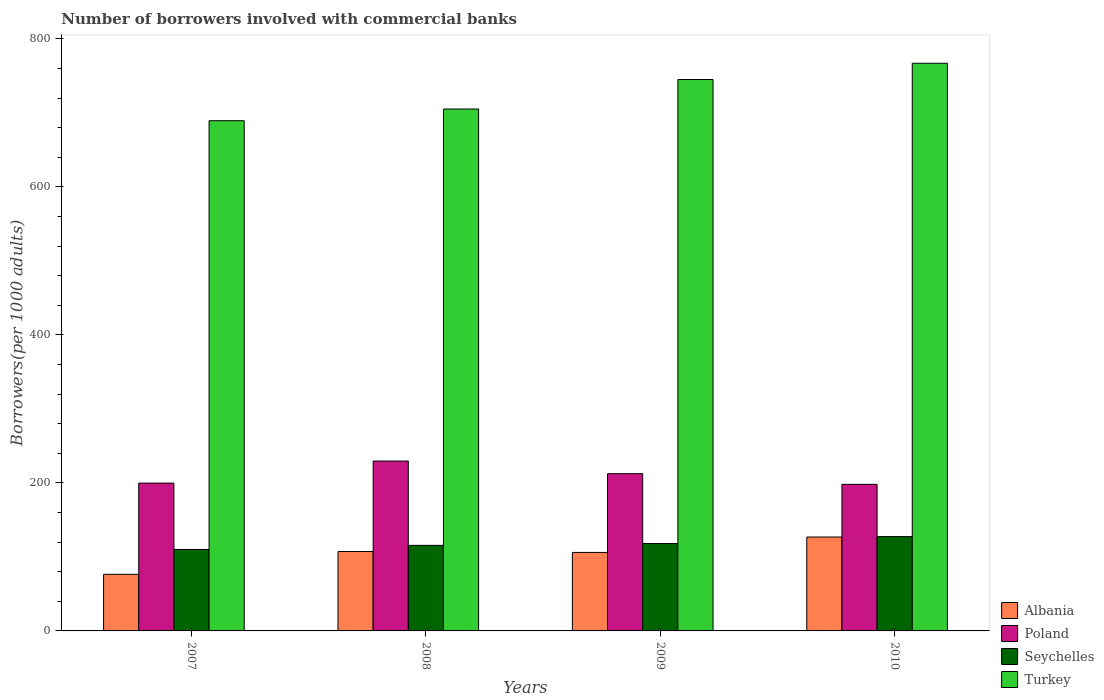How many different coloured bars are there?
Your answer should be compact. 4. How many groups of bars are there?
Provide a succinct answer. 4. Are the number of bars per tick equal to the number of legend labels?
Make the answer very short. Yes. Are the number of bars on each tick of the X-axis equal?
Keep it short and to the point. Yes. In how many cases, is the number of bars for a given year not equal to the number of legend labels?
Make the answer very short. 0. What is the number of borrowers involved with commercial banks in Turkey in 2008?
Your answer should be very brief. 705.18. Across all years, what is the maximum number of borrowers involved with commercial banks in Turkey?
Provide a succinct answer. 766.99. Across all years, what is the minimum number of borrowers involved with commercial banks in Poland?
Ensure brevity in your answer.  198.06. In which year was the number of borrowers involved with commercial banks in Turkey minimum?
Your response must be concise. 2007. What is the total number of borrowers involved with commercial banks in Turkey in the graph?
Offer a terse response. 2906.56. What is the difference between the number of borrowers involved with commercial banks in Turkey in 2007 and that in 2010?
Provide a short and direct response. -77.65. What is the difference between the number of borrowers involved with commercial banks in Seychelles in 2010 and the number of borrowers involved with commercial banks in Albania in 2009?
Your answer should be compact. 21.38. What is the average number of borrowers involved with commercial banks in Turkey per year?
Provide a succinct answer. 726.64. In the year 2009, what is the difference between the number of borrowers involved with commercial banks in Poland and number of borrowers involved with commercial banks in Albania?
Provide a short and direct response. 106.4. What is the ratio of the number of borrowers involved with commercial banks in Albania in 2007 to that in 2010?
Provide a short and direct response. 0.6. Is the number of borrowers involved with commercial banks in Poland in 2007 less than that in 2010?
Ensure brevity in your answer.  No. What is the difference between the highest and the second highest number of borrowers involved with commercial banks in Seychelles?
Offer a terse response. 9.37. What is the difference between the highest and the lowest number of borrowers involved with commercial banks in Seychelles?
Provide a short and direct response. 17.37. Is it the case that in every year, the sum of the number of borrowers involved with commercial banks in Turkey and number of borrowers involved with commercial banks in Seychelles is greater than the sum of number of borrowers involved with commercial banks in Albania and number of borrowers involved with commercial banks in Poland?
Offer a terse response. Yes. What does the 4th bar from the left in 2010 represents?
Give a very brief answer. Turkey. Is it the case that in every year, the sum of the number of borrowers involved with commercial banks in Turkey and number of borrowers involved with commercial banks in Albania is greater than the number of borrowers involved with commercial banks in Seychelles?
Make the answer very short. Yes. How many bars are there?
Offer a terse response. 16. Where does the legend appear in the graph?
Provide a succinct answer. Bottom right. How many legend labels are there?
Give a very brief answer. 4. What is the title of the graph?
Provide a succinct answer. Number of borrowers involved with commercial banks. What is the label or title of the X-axis?
Ensure brevity in your answer.  Years. What is the label or title of the Y-axis?
Provide a short and direct response. Borrowers(per 1000 adults). What is the Borrowers(per 1000 adults) in Albania in 2007?
Provide a short and direct response. 76.5. What is the Borrowers(per 1000 adults) of Poland in 2007?
Offer a very short reply. 199.74. What is the Borrowers(per 1000 adults) in Seychelles in 2007?
Give a very brief answer. 110.06. What is the Borrowers(per 1000 adults) in Turkey in 2007?
Make the answer very short. 689.34. What is the Borrowers(per 1000 adults) in Albania in 2008?
Provide a succinct answer. 107.27. What is the Borrowers(per 1000 adults) of Poland in 2008?
Keep it short and to the point. 229.51. What is the Borrowers(per 1000 adults) in Seychelles in 2008?
Ensure brevity in your answer.  115.61. What is the Borrowers(per 1000 adults) of Turkey in 2008?
Your answer should be compact. 705.18. What is the Borrowers(per 1000 adults) of Albania in 2009?
Keep it short and to the point. 106.05. What is the Borrowers(per 1000 adults) in Poland in 2009?
Provide a succinct answer. 212.45. What is the Borrowers(per 1000 adults) of Seychelles in 2009?
Your response must be concise. 118.06. What is the Borrowers(per 1000 adults) of Turkey in 2009?
Your answer should be very brief. 745.06. What is the Borrowers(per 1000 adults) of Albania in 2010?
Give a very brief answer. 126.87. What is the Borrowers(per 1000 adults) in Poland in 2010?
Keep it short and to the point. 198.06. What is the Borrowers(per 1000 adults) in Seychelles in 2010?
Provide a short and direct response. 127.43. What is the Borrowers(per 1000 adults) of Turkey in 2010?
Give a very brief answer. 766.99. Across all years, what is the maximum Borrowers(per 1000 adults) in Albania?
Your answer should be compact. 126.87. Across all years, what is the maximum Borrowers(per 1000 adults) of Poland?
Provide a short and direct response. 229.51. Across all years, what is the maximum Borrowers(per 1000 adults) in Seychelles?
Give a very brief answer. 127.43. Across all years, what is the maximum Borrowers(per 1000 adults) in Turkey?
Give a very brief answer. 766.99. Across all years, what is the minimum Borrowers(per 1000 adults) of Albania?
Provide a succinct answer. 76.5. Across all years, what is the minimum Borrowers(per 1000 adults) in Poland?
Offer a terse response. 198.06. Across all years, what is the minimum Borrowers(per 1000 adults) in Seychelles?
Make the answer very short. 110.06. Across all years, what is the minimum Borrowers(per 1000 adults) of Turkey?
Your answer should be compact. 689.34. What is the total Borrowers(per 1000 adults) of Albania in the graph?
Keep it short and to the point. 416.68. What is the total Borrowers(per 1000 adults) in Poland in the graph?
Your answer should be compact. 839.76. What is the total Borrowers(per 1000 adults) of Seychelles in the graph?
Provide a short and direct response. 471.15. What is the total Borrowers(per 1000 adults) in Turkey in the graph?
Offer a terse response. 2906.56. What is the difference between the Borrowers(per 1000 adults) of Albania in 2007 and that in 2008?
Provide a short and direct response. -30.78. What is the difference between the Borrowers(per 1000 adults) of Poland in 2007 and that in 2008?
Make the answer very short. -29.78. What is the difference between the Borrowers(per 1000 adults) in Seychelles in 2007 and that in 2008?
Provide a succinct answer. -5.55. What is the difference between the Borrowers(per 1000 adults) of Turkey in 2007 and that in 2008?
Offer a terse response. -15.83. What is the difference between the Borrowers(per 1000 adults) of Albania in 2007 and that in 2009?
Give a very brief answer. -29.55. What is the difference between the Borrowers(per 1000 adults) in Poland in 2007 and that in 2009?
Offer a terse response. -12.71. What is the difference between the Borrowers(per 1000 adults) in Seychelles in 2007 and that in 2009?
Offer a very short reply. -8. What is the difference between the Borrowers(per 1000 adults) of Turkey in 2007 and that in 2009?
Ensure brevity in your answer.  -55.72. What is the difference between the Borrowers(per 1000 adults) of Albania in 2007 and that in 2010?
Your answer should be compact. -50.37. What is the difference between the Borrowers(per 1000 adults) in Poland in 2007 and that in 2010?
Your response must be concise. 1.67. What is the difference between the Borrowers(per 1000 adults) in Seychelles in 2007 and that in 2010?
Offer a very short reply. -17.37. What is the difference between the Borrowers(per 1000 adults) in Turkey in 2007 and that in 2010?
Keep it short and to the point. -77.65. What is the difference between the Borrowers(per 1000 adults) of Albania in 2008 and that in 2009?
Provide a succinct answer. 1.23. What is the difference between the Borrowers(per 1000 adults) of Poland in 2008 and that in 2009?
Make the answer very short. 17.07. What is the difference between the Borrowers(per 1000 adults) of Seychelles in 2008 and that in 2009?
Your answer should be compact. -2.45. What is the difference between the Borrowers(per 1000 adults) of Turkey in 2008 and that in 2009?
Your answer should be very brief. -39.88. What is the difference between the Borrowers(per 1000 adults) of Albania in 2008 and that in 2010?
Your answer should be compact. -19.59. What is the difference between the Borrowers(per 1000 adults) in Poland in 2008 and that in 2010?
Keep it short and to the point. 31.45. What is the difference between the Borrowers(per 1000 adults) in Seychelles in 2008 and that in 2010?
Your response must be concise. -11.82. What is the difference between the Borrowers(per 1000 adults) in Turkey in 2008 and that in 2010?
Make the answer very short. -61.81. What is the difference between the Borrowers(per 1000 adults) in Albania in 2009 and that in 2010?
Your answer should be compact. -20.82. What is the difference between the Borrowers(per 1000 adults) in Poland in 2009 and that in 2010?
Your answer should be very brief. 14.38. What is the difference between the Borrowers(per 1000 adults) in Seychelles in 2009 and that in 2010?
Keep it short and to the point. -9.37. What is the difference between the Borrowers(per 1000 adults) in Turkey in 2009 and that in 2010?
Your answer should be compact. -21.93. What is the difference between the Borrowers(per 1000 adults) in Albania in 2007 and the Borrowers(per 1000 adults) in Poland in 2008?
Ensure brevity in your answer.  -153.02. What is the difference between the Borrowers(per 1000 adults) in Albania in 2007 and the Borrowers(per 1000 adults) in Seychelles in 2008?
Give a very brief answer. -39.11. What is the difference between the Borrowers(per 1000 adults) in Albania in 2007 and the Borrowers(per 1000 adults) in Turkey in 2008?
Ensure brevity in your answer.  -628.68. What is the difference between the Borrowers(per 1000 adults) in Poland in 2007 and the Borrowers(per 1000 adults) in Seychelles in 2008?
Keep it short and to the point. 84.13. What is the difference between the Borrowers(per 1000 adults) of Poland in 2007 and the Borrowers(per 1000 adults) of Turkey in 2008?
Provide a short and direct response. -505.44. What is the difference between the Borrowers(per 1000 adults) of Seychelles in 2007 and the Borrowers(per 1000 adults) of Turkey in 2008?
Give a very brief answer. -595.12. What is the difference between the Borrowers(per 1000 adults) of Albania in 2007 and the Borrowers(per 1000 adults) of Poland in 2009?
Your answer should be compact. -135.95. What is the difference between the Borrowers(per 1000 adults) of Albania in 2007 and the Borrowers(per 1000 adults) of Seychelles in 2009?
Provide a succinct answer. -41.56. What is the difference between the Borrowers(per 1000 adults) in Albania in 2007 and the Borrowers(per 1000 adults) in Turkey in 2009?
Your answer should be compact. -668.56. What is the difference between the Borrowers(per 1000 adults) in Poland in 2007 and the Borrowers(per 1000 adults) in Seychelles in 2009?
Give a very brief answer. 81.68. What is the difference between the Borrowers(per 1000 adults) in Poland in 2007 and the Borrowers(per 1000 adults) in Turkey in 2009?
Keep it short and to the point. -545.32. What is the difference between the Borrowers(per 1000 adults) in Seychelles in 2007 and the Borrowers(per 1000 adults) in Turkey in 2009?
Provide a succinct answer. -635. What is the difference between the Borrowers(per 1000 adults) of Albania in 2007 and the Borrowers(per 1000 adults) of Poland in 2010?
Offer a terse response. -121.57. What is the difference between the Borrowers(per 1000 adults) of Albania in 2007 and the Borrowers(per 1000 adults) of Seychelles in 2010?
Ensure brevity in your answer.  -50.93. What is the difference between the Borrowers(per 1000 adults) in Albania in 2007 and the Borrowers(per 1000 adults) in Turkey in 2010?
Provide a short and direct response. -690.49. What is the difference between the Borrowers(per 1000 adults) of Poland in 2007 and the Borrowers(per 1000 adults) of Seychelles in 2010?
Offer a very short reply. 72.31. What is the difference between the Borrowers(per 1000 adults) of Poland in 2007 and the Borrowers(per 1000 adults) of Turkey in 2010?
Make the answer very short. -567.25. What is the difference between the Borrowers(per 1000 adults) in Seychelles in 2007 and the Borrowers(per 1000 adults) in Turkey in 2010?
Your answer should be compact. -656.93. What is the difference between the Borrowers(per 1000 adults) of Albania in 2008 and the Borrowers(per 1000 adults) of Poland in 2009?
Make the answer very short. -105.17. What is the difference between the Borrowers(per 1000 adults) of Albania in 2008 and the Borrowers(per 1000 adults) of Seychelles in 2009?
Ensure brevity in your answer.  -10.78. What is the difference between the Borrowers(per 1000 adults) in Albania in 2008 and the Borrowers(per 1000 adults) in Turkey in 2009?
Offer a very short reply. -637.78. What is the difference between the Borrowers(per 1000 adults) in Poland in 2008 and the Borrowers(per 1000 adults) in Seychelles in 2009?
Offer a terse response. 111.46. What is the difference between the Borrowers(per 1000 adults) in Poland in 2008 and the Borrowers(per 1000 adults) in Turkey in 2009?
Your response must be concise. -515.54. What is the difference between the Borrowers(per 1000 adults) of Seychelles in 2008 and the Borrowers(per 1000 adults) of Turkey in 2009?
Keep it short and to the point. -629.45. What is the difference between the Borrowers(per 1000 adults) of Albania in 2008 and the Borrowers(per 1000 adults) of Poland in 2010?
Provide a short and direct response. -90.79. What is the difference between the Borrowers(per 1000 adults) of Albania in 2008 and the Borrowers(per 1000 adults) of Seychelles in 2010?
Offer a terse response. -20.15. What is the difference between the Borrowers(per 1000 adults) in Albania in 2008 and the Borrowers(per 1000 adults) in Turkey in 2010?
Offer a very short reply. -659.71. What is the difference between the Borrowers(per 1000 adults) of Poland in 2008 and the Borrowers(per 1000 adults) of Seychelles in 2010?
Offer a very short reply. 102.09. What is the difference between the Borrowers(per 1000 adults) in Poland in 2008 and the Borrowers(per 1000 adults) in Turkey in 2010?
Ensure brevity in your answer.  -537.47. What is the difference between the Borrowers(per 1000 adults) of Seychelles in 2008 and the Borrowers(per 1000 adults) of Turkey in 2010?
Your response must be concise. -651.38. What is the difference between the Borrowers(per 1000 adults) in Albania in 2009 and the Borrowers(per 1000 adults) in Poland in 2010?
Ensure brevity in your answer.  -92.02. What is the difference between the Borrowers(per 1000 adults) of Albania in 2009 and the Borrowers(per 1000 adults) of Seychelles in 2010?
Your response must be concise. -21.38. What is the difference between the Borrowers(per 1000 adults) in Albania in 2009 and the Borrowers(per 1000 adults) in Turkey in 2010?
Your answer should be very brief. -660.94. What is the difference between the Borrowers(per 1000 adults) of Poland in 2009 and the Borrowers(per 1000 adults) of Seychelles in 2010?
Your answer should be very brief. 85.02. What is the difference between the Borrowers(per 1000 adults) in Poland in 2009 and the Borrowers(per 1000 adults) in Turkey in 2010?
Offer a very short reply. -554.54. What is the difference between the Borrowers(per 1000 adults) in Seychelles in 2009 and the Borrowers(per 1000 adults) in Turkey in 2010?
Keep it short and to the point. -648.93. What is the average Borrowers(per 1000 adults) of Albania per year?
Make the answer very short. 104.17. What is the average Borrowers(per 1000 adults) in Poland per year?
Your response must be concise. 209.94. What is the average Borrowers(per 1000 adults) of Seychelles per year?
Your answer should be compact. 117.79. What is the average Borrowers(per 1000 adults) in Turkey per year?
Offer a very short reply. 726.64. In the year 2007, what is the difference between the Borrowers(per 1000 adults) in Albania and Borrowers(per 1000 adults) in Poland?
Make the answer very short. -123.24. In the year 2007, what is the difference between the Borrowers(per 1000 adults) in Albania and Borrowers(per 1000 adults) in Seychelles?
Provide a succinct answer. -33.56. In the year 2007, what is the difference between the Borrowers(per 1000 adults) in Albania and Borrowers(per 1000 adults) in Turkey?
Provide a succinct answer. -612.85. In the year 2007, what is the difference between the Borrowers(per 1000 adults) of Poland and Borrowers(per 1000 adults) of Seychelles?
Offer a very short reply. 89.68. In the year 2007, what is the difference between the Borrowers(per 1000 adults) of Poland and Borrowers(per 1000 adults) of Turkey?
Provide a succinct answer. -489.61. In the year 2007, what is the difference between the Borrowers(per 1000 adults) of Seychelles and Borrowers(per 1000 adults) of Turkey?
Offer a very short reply. -579.28. In the year 2008, what is the difference between the Borrowers(per 1000 adults) in Albania and Borrowers(per 1000 adults) in Poland?
Your response must be concise. -122.24. In the year 2008, what is the difference between the Borrowers(per 1000 adults) in Albania and Borrowers(per 1000 adults) in Seychelles?
Your answer should be very brief. -8.33. In the year 2008, what is the difference between the Borrowers(per 1000 adults) of Albania and Borrowers(per 1000 adults) of Turkey?
Provide a succinct answer. -597.9. In the year 2008, what is the difference between the Borrowers(per 1000 adults) in Poland and Borrowers(per 1000 adults) in Seychelles?
Provide a succinct answer. 113.91. In the year 2008, what is the difference between the Borrowers(per 1000 adults) in Poland and Borrowers(per 1000 adults) in Turkey?
Offer a very short reply. -475.66. In the year 2008, what is the difference between the Borrowers(per 1000 adults) in Seychelles and Borrowers(per 1000 adults) in Turkey?
Your answer should be compact. -589.57. In the year 2009, what is the difference between the Borrowers(per 1000 adults) of Albania and Borrowers(per 1000 adults) of Poland?
Provide a succinct answer. -106.4. In the year 2009, what is the difference between the Borrowers(per 1000 adults) in Albania and Borrowers(per 1000 adults) in Seychelles?
Ensure brevity in your answer.  -12.01. In the year 2009, what is the difference between the Borrowers(per 1000 adults) of Albania and Borrowers(per 1000 adults) of Turkey?
Offer a very short reply. -639.01. In the year 2009, what is the difference between the Borrowers(per 1000 adults) of Poland and Borrowers(per 1000 adults) of Seychelles?
Keep it short and to the point. 94.39. In the year 2009, what is the difference between the Borrowers(per 1000 adults) of Poland and Borrowers(per 1000 adults) of Turkey?
Offer a very short reply. -532.61. In the year 2009, what is the difference between the Borrowers(per 1000 adults) of Seychelles and Borrowers(per 1000 adults) of Turkey?
Offer a very short reply. -627. In the year 2010, what is the difference between the Borrowers(per 1000 adults) in Albania and Borrowers(per 1000 adults) in Poland?
Provide a succinct answer. -71.2. In the year 2010, what is the difference between the Borrowers(per 1000 adults) of Albania and Borrowers(per 1000 adults) of Seychelles?
Offer a terse response. -0.56. In the year 2010, what is the difference between the Borrowers(per 1000 adults) of Albania and Borrowers(per 1000 adults) of Turkey?
Give a very brief answer. -640.12. In the year 2010, what is the difference between the Borrowers(per 1000 adults) in Poland and Borrowers(per 1000 adults) in Seychelles?
Provide a succinct answer. 70.64. In the year 2010, what is the difference between the Borrowers(per 1000 adults) of Poland and Borrowers(per 1000 adults) of Turkey?
Offer a terse response. -568.92. In the year 2010, what is the difference between the Borrowers(per 1000 adults) of Seychelles and Borrowers(per 1000 adults) of Turkey?
Provide a short and direct response. -639.56. What is the ratio of the Borrowers(per 1000 adults) in Albania in 2007 to that in 2008?
Ensure brevity in your answer.  0.71. What is the ratio of the Borrowers(per 1000 adults) of Poland in 2007 to that in 2008?
Give a very brief answer. 0.87. What is the ratio of the Borrowers(per 1000 adults) of Turkey in 2007 to that in 2008?
Offer a very short reply. 0.98. What is the ratio of the Borrowers(per 1000 adults) in Albania in 2007 to that in 2009?
Make the answer very short. 0.72. What is the ratio of the Borrowers(per 1000 adults) in Poland in 2007 to that in 2009?
Make the answer very short. 0.94. What is the ratio of the Borrowers(per 1000 adults) of Seychelles in 2007 to that in 2009?
Keep it short and to the point. 0.93. What is the ratio of the Borrowers(per 1000 adults) in Turkey in 2007 to that in 2009?
Make the answer very short. 0.93. What is the ratio of the Borrowers(per 1000 adults) of Albania in 2007 to that in 2010?
Ensure brevity in your answer.  0.6. What is the ratio of the Borrowers(per 1000 adults) in Poland in 2007 to that in 2010?
Offer a very short reply. 1.01. What is the ratio of the Borrowers(per 1000 adults) of Seychelles in 2007 to that in 2010?
Your response must be concise. 0.86. What is the ratio of the Borrowers(per 1000 adults) in Turkey in 2007 to that in 2010?
Your answer should be compact. 0.9. What is the ratio of the Borrowers(per 1000 adults) of Albania in 2008 to that in 2009?
Ensure brevity in your answer.  1.01. What is the ratio of the Borrowers(per 1000 adults) in Poland in 2008 to that in 2009?
Keep it short and to the point. 1.08. What is the ratio of the Borrowers(per 1000 adults) of Seychelles in 2008 to that in 2009?
Provide a short and direct response. 0.98. What is the ratio of the Borrowers(per 1000 adults) in Turkey in 2008 to that in 2009?
Provide a succinct answer. 0.95. What is the ratio of the Borrowers(per 1000 adults) in Albania in 2008 to that in 2010?
Offer a very short reply. 0.85. What is the ratio of the Borrowers(per 1000 adults) of Poland in 2008 to that in 2010?
Your answer should be compact. 1.16. What is the ratio of the Borrowers(per 1000 adults) of Seychelles in 2008 to that in 2010?
Provide a short and direct response. 0.91. What is the ratio of the Borrowers(per 1000 adults) of Turkey in 2008 to that in 2010?
Give a very brief answer. 0.92. What is the ratio of the Borrowers(per 1000 adults) of Albania in 2009 to that in 2010?
Your response must be concise. 0.84. What is the ratio of the Borrowers(per 1000 adults) in Poland in 2009 to that in 2010?
Your response must be concise. 1.07. What is the ratio of the Borrowers(per 1000 adults) in Seychelles in 2009 to that in 2010?
Ensure brevity in your answer.  0.93. What is the ratio of the Borrowers(per 1000 adults) of Turkey in 2009 to that in 2010?
Your answer should be very brief. 0.97. What is the difference between the highest and the second highest Borrowers(per 1000 adults) of Albania?
Offer a very short reply. 19.59. What is the difference between the highest and the second highest Borrowers(per 1000 adults) in Poland?
Make the answer very short. 17.07. What is the difference between the highest and the second highest Borrowers(per 1000 adults) in Seychelles?
Keep it short and to the point. 9.37. What is the difference between the highest and the second highest Borrowers(per 1000 adults) of Turkey?
Offer a terse response. 21.93. What is the difference between the highest and the lowest Borrowers(per 1000 adults) of Albania?
Make the answer very short. 50.37. What is the difference between the highest and the lowest Borrowers(per 1000 adults) in Poland?
Your response must be concise. 31.45. What is the difference between the highest and the lowest Borrowers(per 1000 adults) in Seychelles?
Ensure brevity in your answer.  17.37. What is the difference between the highest and the lowest Borrowers(per 1000 adults) of Turkey?
Keep it short and to the point. 77.65. 